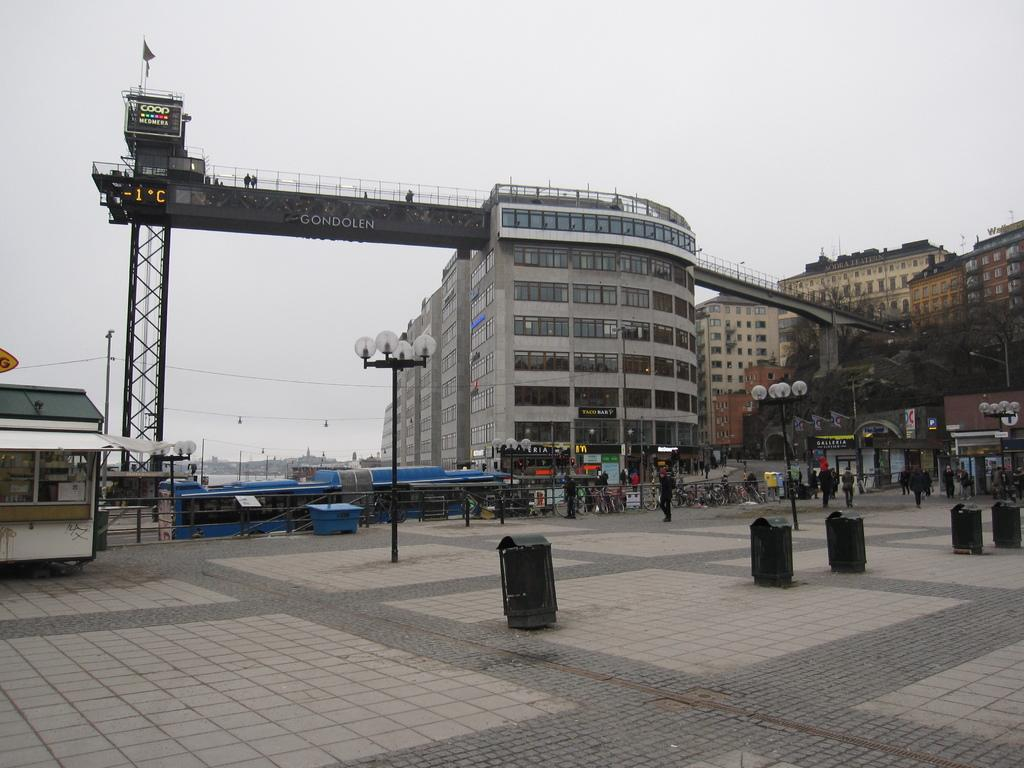What type of vertical structures can be seen in the image? There are light poles in the image. What type of man-made structures are present in the image? There are buildings, a bridge, and railing in the image. What type of symbol can be seen in the image? There is a flag in the image. What type of containers are present in the image? There are bins in the image. What type of horizontal structure can be seen in the image? There is a beam in the image. What type of flat, rigid material can be seen in the image? There are boards in the image. What type of commercial establishments can be seen in the image? There are stores and stalls in the image. What type of surface is visible in the image? There is ground visible in the image. What part of the natural environment is visible in the image? There is sky visible in the image. What type of objects are present in the image? There are objects in the image. Can you see a sponge being used to clean the boards in the image? There is no sponge or cleaning activity visible in the image. What type of glass object can be seen on the bridge in the image? There is no glass object present on the bridge in the image. 